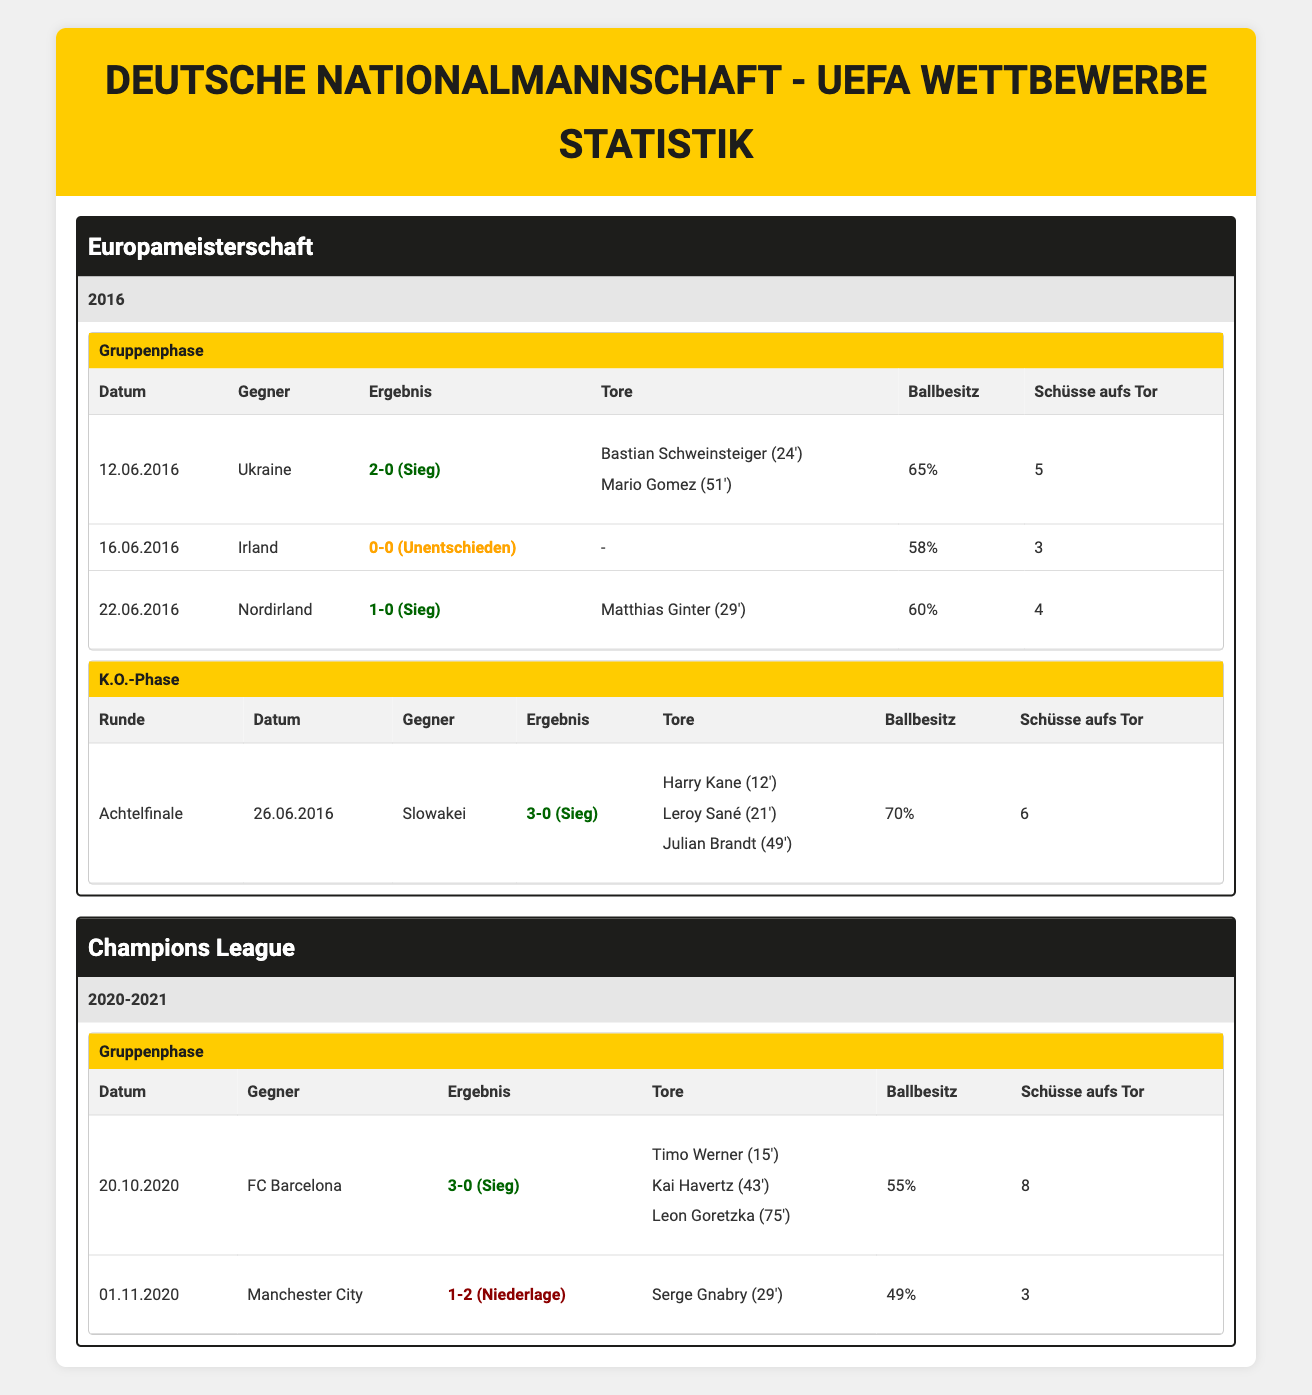What was the result of the match against Ukraine in the Euro Championship 2016? The table indicates that the match against Ukraine was played on June 12, 2016, and the result was a win with a score of 2-0.
Answer: Win How many shots on target did the German national team have during the match against Northern Ireland? According to the table, in the match against Northern Ireland on June 22, 2016, the German team had 4 shots on target.
Answer: 4 Did Germany lose any matches in the Euro Championship 2016? The table shows that the results from all matches played by Germany in Euro Championship 2016 include only wins and one draw, meaning they did not lose any matches.
Answer: No What was the possession percentage in the knockout match against Slovakia? The table states that in the knockout match against Slovakia on June 26, 2016, Germany had a possession percentage of 70%.
Answer: 70% What are the total goals scored by Germany in the Champions League group stage against FC Barcelona? In the match against FC Barcelona on October 20, 2020, the table lists three goals scored by Germany.
Answer: 3 What is the average possession percentage for all matches played by Germany in Euro Championship 2016? The possession percentages were as follows: 65%, 58%, 60%, and 70% in the knockout stage. Adding these percentages gives a total of 253%. There were 4 matches, so the average is 253% / 4 = 63.25%.
Answer: 63.25% How many total goals in the Champions League group stage did Germany score against Manchester City? In the match against Manchester City on November 1, 2020, the table indicates that Germany scored 1 goal, which was made by Serge Gnabry.
Answer: 1 Which match had the highest number of shots on target during UEFA competitions shown in the table? By comparing the number of shots on target among all matches in both competitions, the most significant was 8 shots on target against FC Barcelona on October 20, 2020.
Answer: 8 Did Germany score before the 30th minute in their match against Ireland? The table shows that in the match against Ireland on June 16, 2016, Germany did not score at all, meaning they did not score before the 30th minute.
Answer: No 